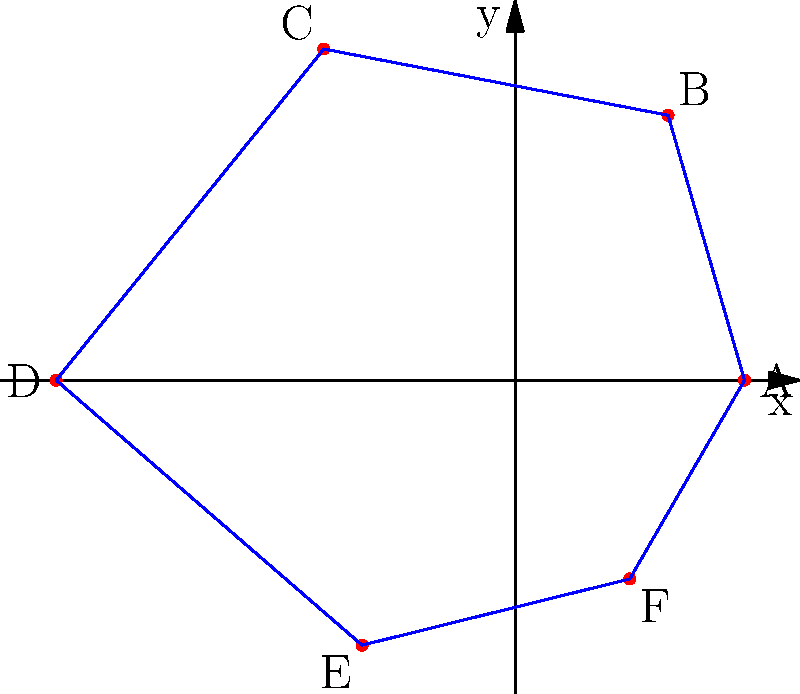The polar network diagram above represents trade routes between six major civilizations (A-F) during a specific historical period. The distance from the center indicates the relative economic power of each civilization, while the connections show established trade routes. Based on this representation, which civilization appears to be the most influential in terms of trade connections and economic power, and how might this oversimplify the complex historical realities of the time? To answer this question, we need to analyze the polar network diagram step-by-step:

1. Evaluate the economic power:
   The distance from the center represents economic power. 
   A: r ≈ 3, B: r ≈ 4, C: r ≈ 5, D: r ≈ 6, E: r ≈ 4, F: r ≈ 3
   Civilization D has the greatest distance, indicating the highest economic power.

2. Assess trade connections:
   Count the number of direct connections for each civilization.
   A: 2, B: 2, C: 2, D: 2, E: 2, F: 2
   All civilizations have an equal number of direct trade routes.

3. Consider the combination of economic power and trade connections:
   Civilization D has the highest economic power and an equal number of trade connections compared to others.

4. Identify the most influential civilization:
   Based on the given information, Civilization D appears to be the most influential.

5. Critical analysis of the simplification:
   This representation oversimplifies historical realities by:
   a) Reducing complex trade relationships to simple lines
   b) Ignoring geographical factors that affect trade
   c) Disregarding cultural and political influences on trade
   d) Presenting a static view of what was likely a dynamic system
   e) Equating economic power solely with distance from the center
   f) Failing to account for the quality or volume of trade along each route
   g) Overlooking indirect trade connections and their importance
   h) Assuming that all civilizations had equal access to trade routes

These simplifications could lead to misinterpretations of the actual historical complexity and nuances of trade relationships and power dynamics between these civilizations.
Answer: Civilization D; oversimplifies by reducing complex trade dynamics to basic visual elements, ignoring crucial historical factors. 